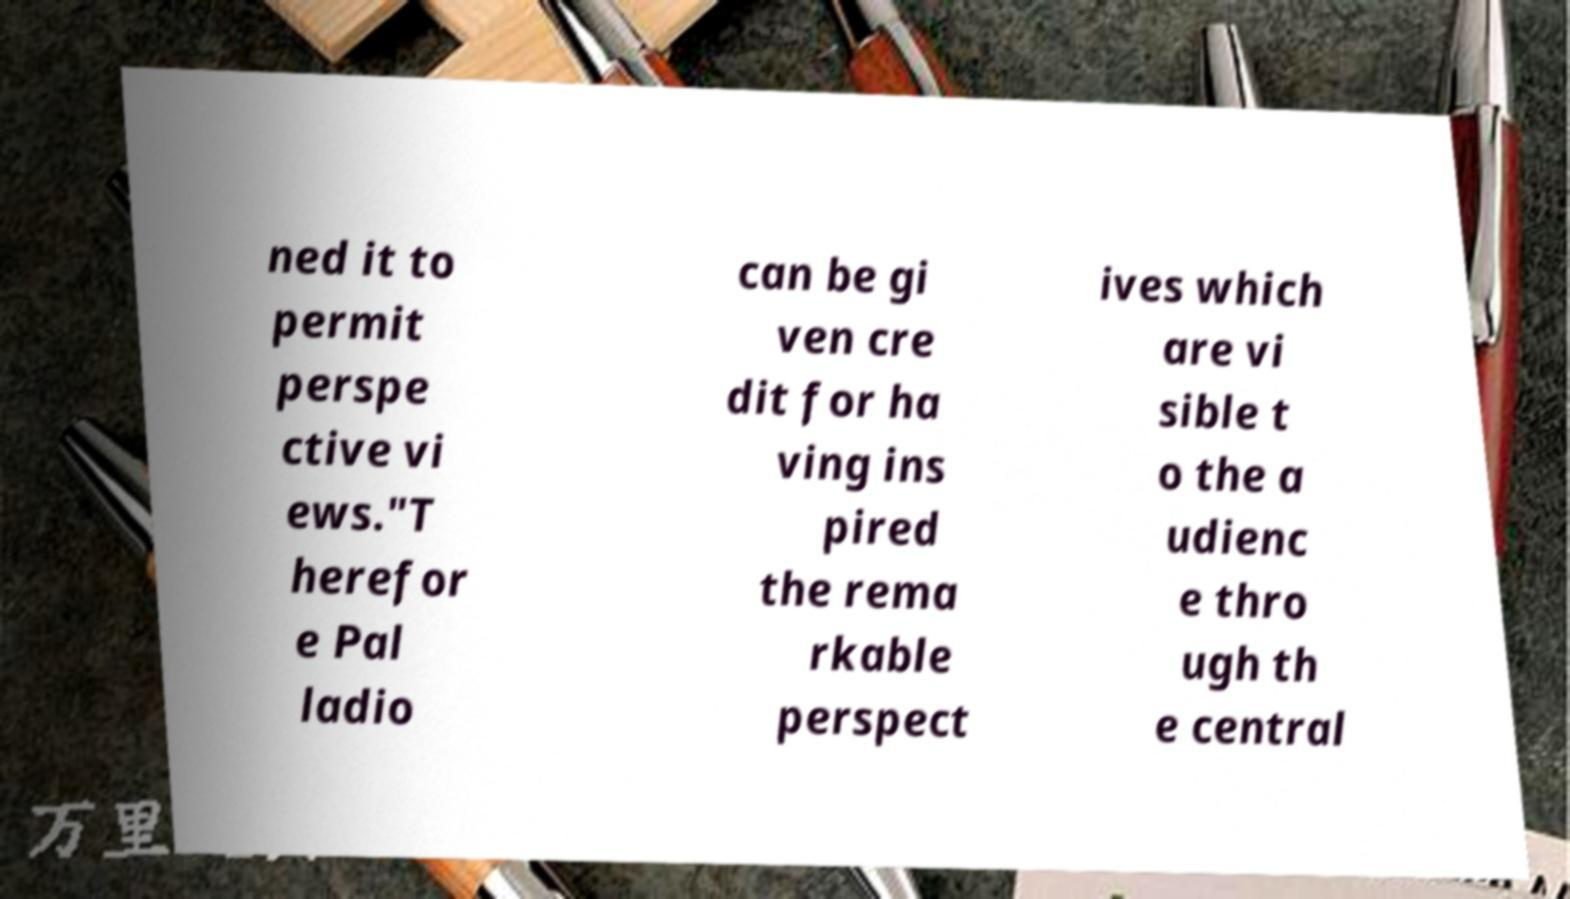Can you accurately transcribe the text from the provided image for me? ned it to permit perspe ctive vi ews."T herefor e Pal ladio can be gi ven cre dit for ha ving ins pired the rema rkable perspect ives which are vi sible t o the a udienc e thro ugh th e central 